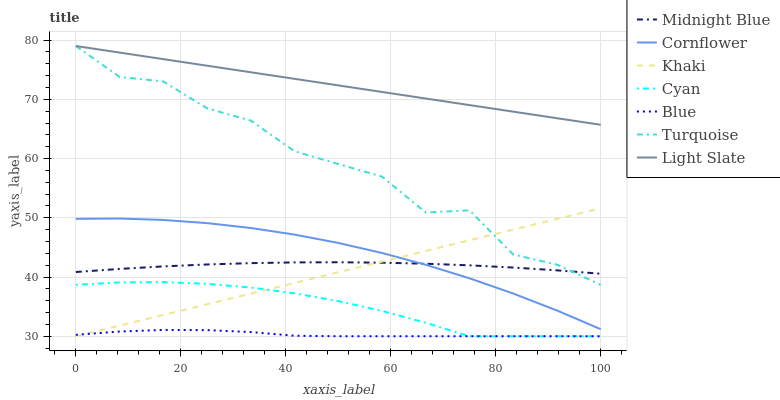Does Blue have the minimum area under the curve?
Answer yes or no. Yes. Does Light Slate have the maximum area under the curve?
Answer yes or no. Yes. Does Cornflower have the minimum area under the curve?
Answer yes or no. No. Does Cornflower have the maximum area under the curve?
Answer yes or no. No. Is Khaki the smoothest?
Answer yes or no. Yes. Is Turquoise the roughest?
Answer yes or no. Yes. Is Cornflower the smoothest?
Answer yes or no. No. Is Cornflower the roughest?
Answer yes or no. No. Does Blue have the lowest value?
Answer yes or no. Yes. Does Cornflower have the lowest value?
Answer yes or no. No. Does Light Slate have the highest value?
Answer yes or no. Yes. Does Cornflower have the highest value?
Answer yes or no. No. Is Cyan less than Light Slate?
Answer yes or no. Yes. Is Light Slate greater than Cornflower?
Answer yes or no. Yes. Does Midnight Blue intersect Khaki?
Answer yes or no. Yes. Is Midnight Blue less than Khaki?
Answer yes or no. No. Is Midnight Blue greater than Khaki?
Answer yes or no. No. Does Cyan intersect Light Slate?
Answer yes or no. No. 